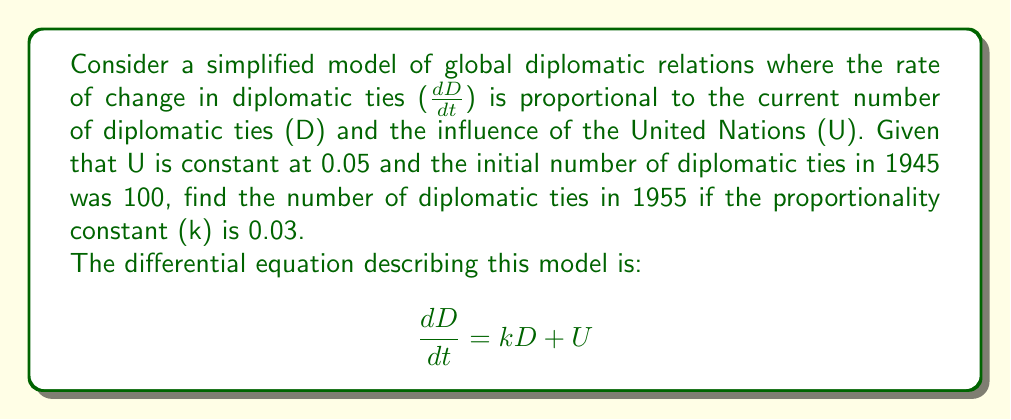Can you solve this math problem? 1) We start with the given differential equation:
   $$\frac{dD}{dt} = kD + U$$

2) Substitute the known values: k = 0.03, U = 0.05
   $$\frac{dD}{dt} = 0.03D + 0.05$$

3) This is a linear first-order differential equation. The general solution is:
   $$D(t) = Ce^{kt} - \frac{U}{k}$$
   where C is a constant of integration.

4) Substitute the known values:
   $$D(t) = Ce^{0.03t} - \frac{0.05}{0.03}$$

5) Use the initial condition: D(0) = 100 (in 1945)
   $$100 = C - \frac{0.05}{0.03}$$
   $$C = 100 + \frac{5}{3} = \frac{305}{3}$$

6) The particular solution is:
   $$D(t) = \frac{305}{3}e^{0.03t} - \frac{5}{3}$$

7) To find D in 1955, we need t = 10 (10 years after 1945):
   $$D(10) = \frac{305}{3}e^{0.3} - \frac{5}{3}$$

8) Calculate:
   $$D(10) = 101.67e^{0.3} - 1.67 \approx 135.91$$
Answer: 135.91 diplomatic ties in 1955 